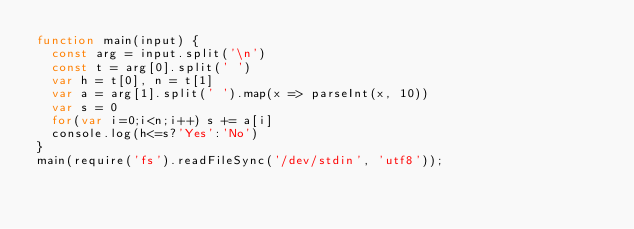<code> <loc_0><loc_0><loc_500><loc_500><_JavaScript_>function main(input) {
  const arg = input.split('\n')
  const t = arg[0].split(' ')
  var h = t[0], n = t[1]
  var a = arg[1].split(' ').map(x => parseInt(x, 10))
  var s = 0
  for(var i=0;i<n;i++) s += a[i]
  console.log(h<=s?'Yes':'No')
}
main(require('fs').readFileSync('/dev/stdin', 'utf8'));
</code> 